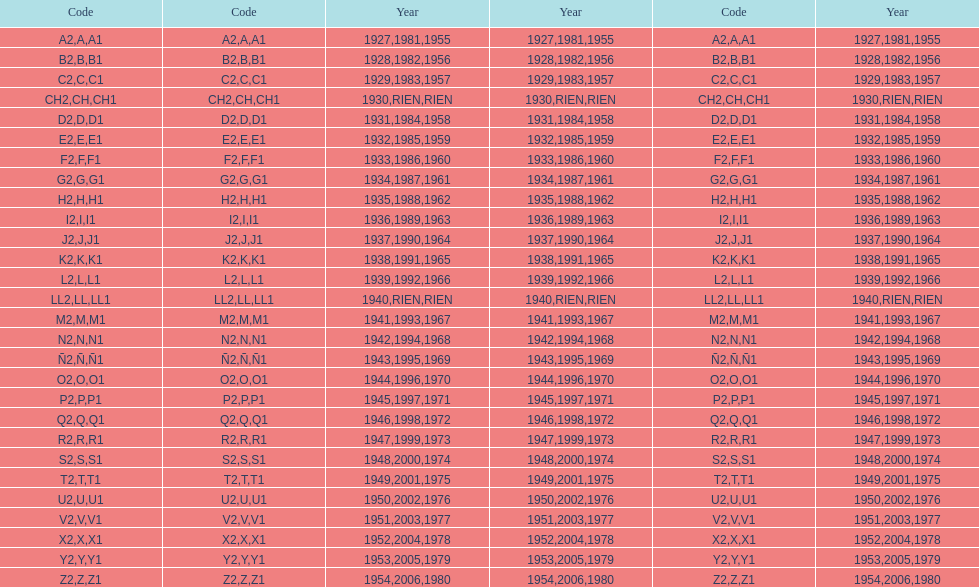Is the e code less than 1950? Yes. 